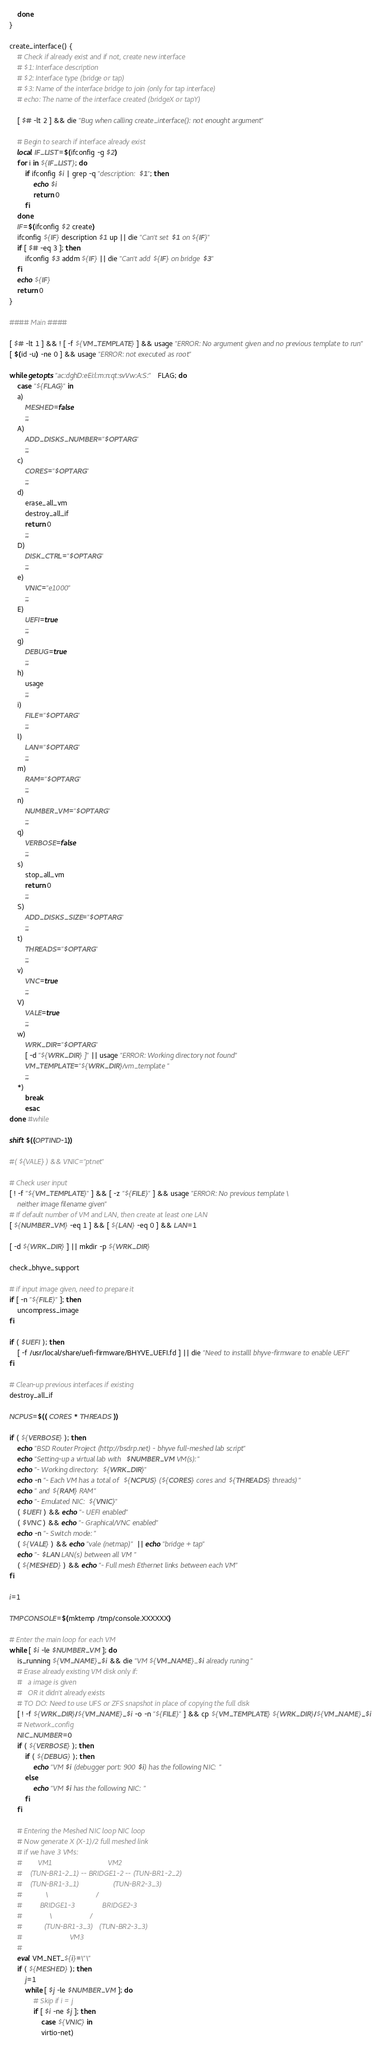Convert code to text. <code><loc_0><loc_0><loc_500><loc_500><_Bash_>
	done
}

create_interface() {
	# Check if already exist and if not, create new interface
	# $1: Interface description
	# $2: Interface type (bridge or tap)
	# $3: Name of the interface bridge to join (only for tap interface)
	# echo: The name of the interface created (bridgeX or tapY)

	[ $# -lt 2 ] && die "Bug when calling create_interface(): not enought argument"

	# Begin to search if interface already exist
	local IF_LIST=$(ifconfig -g $2)
	for i in ${IF_LIST}; do
		if ifconfig $i | grep -q "description: $1"; then
			echo $i
			return 0
		fi
	done
	IF=$(ifconfig $2 create)
	ifconfig ${IF} description $1 up || die "Can't set $1 on ${IF}"
	if [ $# -eq 3 ]; then
		ifconfig $3 addm ${IF} || die "Can't add ${IF} on bridge $3"
	fi
	echo ${IF}
	return 0
}

#### Main ####

[ $# -lt 1 ] && ! [ -f ${VM_TEMPLATE} ] && usage "ERROR: No argument given and no previous template to run"
[ $(id -u) -ne 0 ] && usage "ERROR: not executed as root"

while getopts "ac:dghD:eEi:l:m:n:qt:svVw:A:S:" FLAG; do
    case "${FLAG}" in
	a)
		MESHED=false
		;;
	A)
		ADD_DISKS_NUMBER="$OPTARG"
		;;
	c)
		CORES="$OPTARG"
		;;
	d)
		erase_all_vm
		destroy_all_if
		return 0
		;;
	D)
		DISK_CTRL="$OPTARG"
		;;
	e)
		VNIC="e1000"
		;;
	E)
		UEFI=true
		;;
	g)
		DEBUG=true
		;;
	h)
		usage
		;;
	i)
		FILE="$OPTARG"
        ;;
	l)
		LAN="$OPTARG"
		;;
	m)
		RAM="$OPTARG"
		;;
	n)
		NUMBER_VM="$OPTARG"
		;;
	q)
		VERBOSE=false
		;;
	s)
		stop_all_vm
		return 0
		;;
	S)
		ADD_DISKS_SIZE="$OPTARG"
		;;
	t)
		THREADS="$OPTARG"
		;;
	v)
		VNC=true
		;;
	V)
		VALE=true
		;;
	w)
		WRK_DIR="$OPTARG"
		[ -d "${WRK_DIR} ]" || usage "ERROR: Working directory not found"
		VM_TEMPLATE="${WRK_DIR}/vm_template"
		;;
	*)
		break
        esac
done #while

shift $((OPTIND-1))

#( ${VALE} ) && VNIC="ptnet"

# Check user input
[ ! -f "${VM_TEMPLATE}" ] && [ -z "${FILE}" ] && usage "ERROR: No previous template \
	neither image filename given"
# If default number of VM and LAN, then create at least one LAN
[ ${NUMBER_VM} -eq 1 ] && [ ${LAN} -eq 0 ] && LAN=1

[ -d ${WRK_DIR} ] || mkdir -p ${WRK_DIR}

check_bhyve_support

# if input image given, need to prepare it
if [ -n "${FILE}" ]; then
	uncompress_image
fi

if ( $UEFI ); then
	[ -f /usr/local/share/uefi-firmware/BHYVE_UEFI.fd ] || die "Need to installl bhyve-firmware to enable UEFI"
fi

# Clean-up previous interfaces if existing
destroy_all_if

NCPUS=$(( CORES * THREADS ))

if ( ${VERBOSE} ); then
	echo "BSD Router Project (http://bsdrp.net) - bhyve full-meshed lab script"
	echo "Setting-up a virtual lab with $NUMBER_VM VM(s):"
	echo "- Working directory: ${WRK_DIR}"
	echo -n "- Each VM has a total of ${NCPUS} (${CORES} cores and ${THREADS} threads)"
	echo " and ${RAM} RAM"
	echo "- Emulated NIC: ${VNIC}"
	( $UEFI ) && echo "- UEFI enabled"
	( $VNC ) && echo "- Graphical/VNC enabled"
	echo -n "- Switch mode: "
	( ${VALE} ) && echo "vale (netmap)" || echo "bridge + tap"
	echo "- $LAN LAN(s) between all VM"
	( ${MESHED} ) && echo "- Full mesh Ethernet links between each VM"
fi

i=1

TMPCONSOLE=$(mktemp /tmp/console.XXXXXX)

# Enter the main loop for each VM
while [ $i -le $NUMBER_VM ]; do
	is_running ${VM_NAME}_$i && die "VM ${VM_NAME}_$i already runing"
	# Erase already existing VM disk only if:
	#   a image is given
	#   OR it didn't already exists
	# TO DO: Need to use UFS or ZFS snapshot in place of copying the full disk
	[ ! -f ${WRK_DIR}/${VM_NAME}_$i -o -n "${FILE}" ] && cp ${VM_TEMPLATE} ${WRK_DIR}/${VM_NAME}_$i
	# Network_config
	NIC_NUMBER=0
    if ( ${VERBOSE} ); then
		if ( ${DEBUG} ); then
			echo "VM $i (debugger port: 900$i) has the following NIC:"
		else
			echo "VM $i has the following NIC:"
		fi
	fi

	# Entering the Meshed NIC loop NIC loop
	# Now generate X (X-1)/2 full meshed link
	# if we have 3 VMs:
	#        VM1                            VM2
	#    (TUN-BR1-2_1) -- BRIDGE1-2 -- (TUN-BR1-2_2)
	#    (TUN-BR1-3_1)                 (TUN-BR2-3_3)
	#            \                        /
	#         BRIDGE1-3              BRIDGE2-3
	#              \                   /
	#           (TUN-BR1-3_3)   (TUN-BR2-3_3)
	#                        VM3
	#
	eval VM_NET_${i}=\"\"
	if ( ${MESHED} ); then
		j=1
		while [ $j -le $NUMBER_VM ]; do
			# Skip if i = j
			if [ $i -ne $j ]; then
				case ${VNIC} in
				virtio-net)</code> 